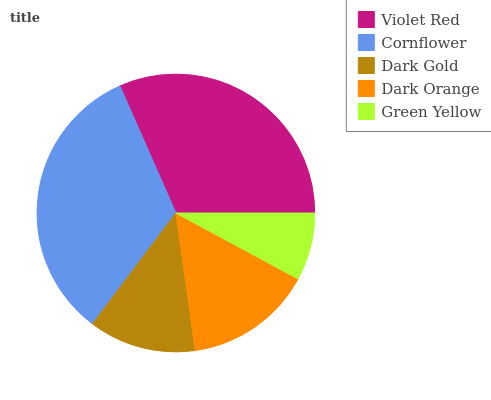Is Green Yellow the minimum?
Answer yes or no. Yes. Is Cornflower the maximum?
Answer yes or no. Yes. Is Dark Gold the minimum?
Answer yes or no. No. Is Dark Gold the maximum?
Answer yes or no. No. Is Cornflower greater than Dark Gold?
Answer yes or no. Yes. Is Dark Gold less than Cornflower?
Answer yes or no. Yes. Is Dark Gold greater than Cornflower?
Answer yes or no. No. Is Cornflower less than Dark Gold?
Answer yes or no. No. Is Dark Orange the high median?
Answer yes or no. Yes. Is Dark Orange the low median?
Answer yes or no. Yes. Is Green Yellow the high median?
Answer yes or no. No. Is Dark Gold the low median?
Answer yes or no. No. 